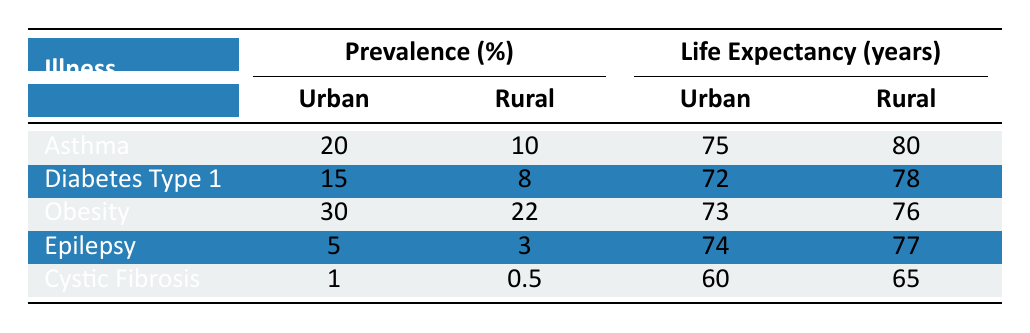What is the prevalence of asthma in urban populations? The table indicates that the prevalence of asthma in urban populations is 20%.
Answer: 20% Which illness has the highest urban prevalence? According to the table, obesity has the highest urban prevalence at 30%.
Answer: Obesity What is the life expectancy for children with diabetes type 1 in rural areas? The life expectancy for children with diabetes type 1 in rural areas is 78 years, as shown in the table.
Answer: 78 Is the life expectancy for patients with cystic fibrosis higher in rural areas than in urban areas? Yes, the table shows a life expectancy of 65 years for rural cystic fibrosis patients, compared to 60 years for urban patients.
Answer: Yes What is the difference in life expectancy for obesity between urban and rural populations? The urban life expectancy for obesity is 73 years, whereas the rural life expectancy is 76 years. The difference is 76 - 73 = 3 years.
Answer: 3 years How does the urban prevalence of epilepsy compare to that of diabetes type 1? Epilepsy has an urban prevalence of 5%, while diabetes type 1 has an urban prevalence of 15%. Diabetes type 1 is therefore more prevalent by 15 - 5 = 10%.
Answer: 10% What is the average life expectancy for children with chronic illnesses in urban areas? The average life expectancy can be calculated by summing the urban life expectancies: (75 + 72 + 73 + 74 + 60) = 354 years. Dividing by the number of illnesses (5) gives us 354/5 = 70.8 years.
Answer: 70.8 years Which chronic illness has the lowest prevalence in rural areas? Cystic fibrosis has the lowest prevalence in rural areas at 0.5%, according to the table.
Answer: Cystic Fibrosis What is the combined urban prevalence of asthma and obesity? The combined urban prevalence can be calculated by adding the urban prevalences of asthma (20%) and obesity (30%): 20 + 30 = 50%.
Answer: 50% 